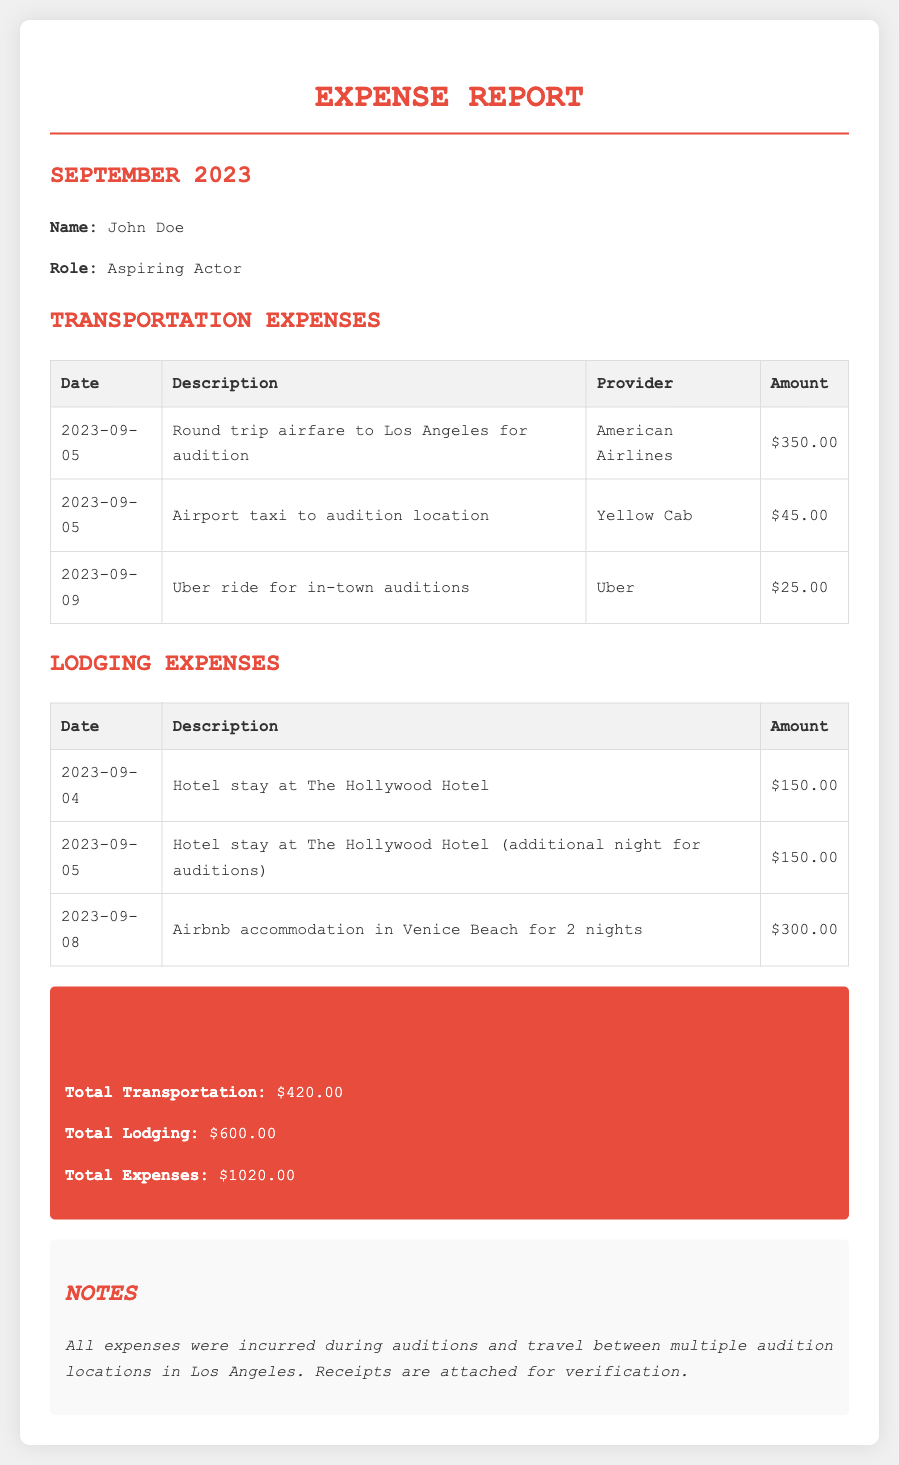What is the name of the actor? The document states the name of the actor as John Doe.
Answer: John Doe What is the total amount spent on transportation? The total transportation expenses listed in the document are $350.00 + $45.00 + $25.00, totaling $420.00.
Answer: $420.00 What date was the Airbnb accommodation booked? The Airbnb accommodation was booked on September 8, 2023, as indicated in the lodging expenses.
Answer: 2023-09-08 How many nights was the Airbnb stay? The document states that the Airbnb accommodation was for 2 nights.
Answer: 2 nights What is the total lodging expense? The total lodging expenses detailed are $150.00 + $150.00 + $300.00, summing up to $600.00.
Answer: $600.00 What type of document is this? This document outlines expenses related to travel for auditions, categorized into transportation and lodging.
Answer: Expense Report Which provider was used for the round trip airfare? The provider for the airfare as mentioned in the document is American Airlines.
Answer: American Airlines What is the total amount of expenses? The document sums up all expenses, which include both transportation and lodging, for a total of $1020.00.
Answer: $1020.00 What were the dates of travel for auditions? The first travel date mentioned in the transportation expenses is September 5, 2023, indicating travel was primarily around that time.
Answer: September 5, 2023 